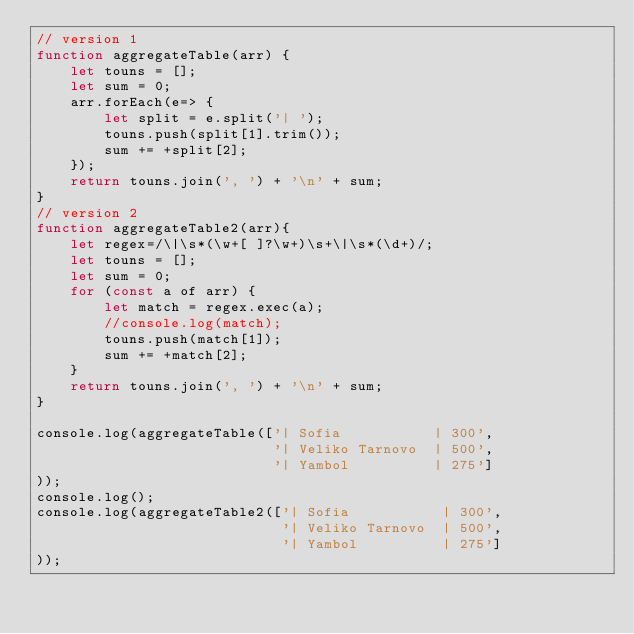Convert code to text. <code><loc_0><loc_0><loc_500><loc_500><_JavaScript_>// version 1
function aggregateTable(arr) {
    let touns = [];
    let sum = 0;
    arr.forEach(e=> {
        let split = e.split('| ');
        touns.push(split[1].trim());
        sum += +split[2];
    });
    return touns.join(', ') + '\n' + sum;
}
// version 2
function aggregateTable2(arr){
    let regex=/\|\s*(\w+[ ]?\w+)\s+\|\s*(\d+)/;
    let touns = [];
    let sum = 0;
    for (const a of arr) {
        let match = regex.exec(a);
        //console.log(match);
        touns.push(match[1]);
        sum += +match[2];
    }
    return touns.join(', ') + '\n' + sum;
}

console.log(aggregateTable(['| Sofia           | 300',
                            '| Veliko Tarnovo  | 500',
                            '| Yambol          | 275']
));
console.log();
console.log(aggregateTable2(['| Sofia           | 300',
                             '| Veliko Tarnovo  | 500',
                             '| Yambol          | 275']
));</code> 